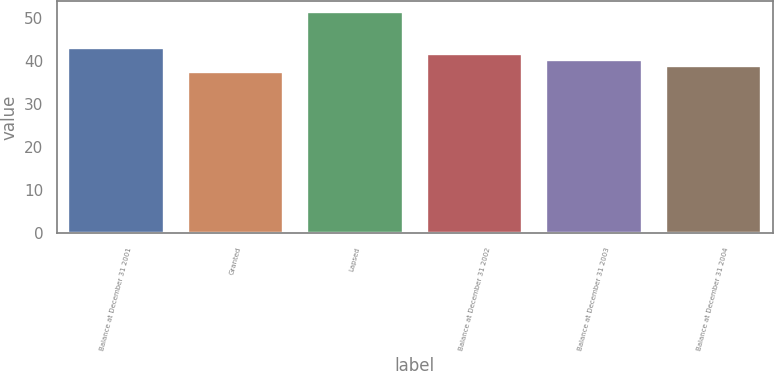Convert chart to OTSL. <chart><loc_0><loc_0><loc_500><loc_500><bar_chart><fcel>Balance at December 31 2001<fcel>Granted<fcel>Lapsed<fcel>Balance at December 31 2002<fcel>Balance at December 31 2003<fcel>Balance at December 31 2004<nl><fcel>43.11<fcel>37.55<fcel>51.44<fcel>41.72<fcel>40.33<fcel>38.94<nl></chart> 